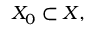Convert formula to latex. <formula><loc_0><loc_0><loc_500><loc_500>X _ { 0 } \subset X ,</formula> 